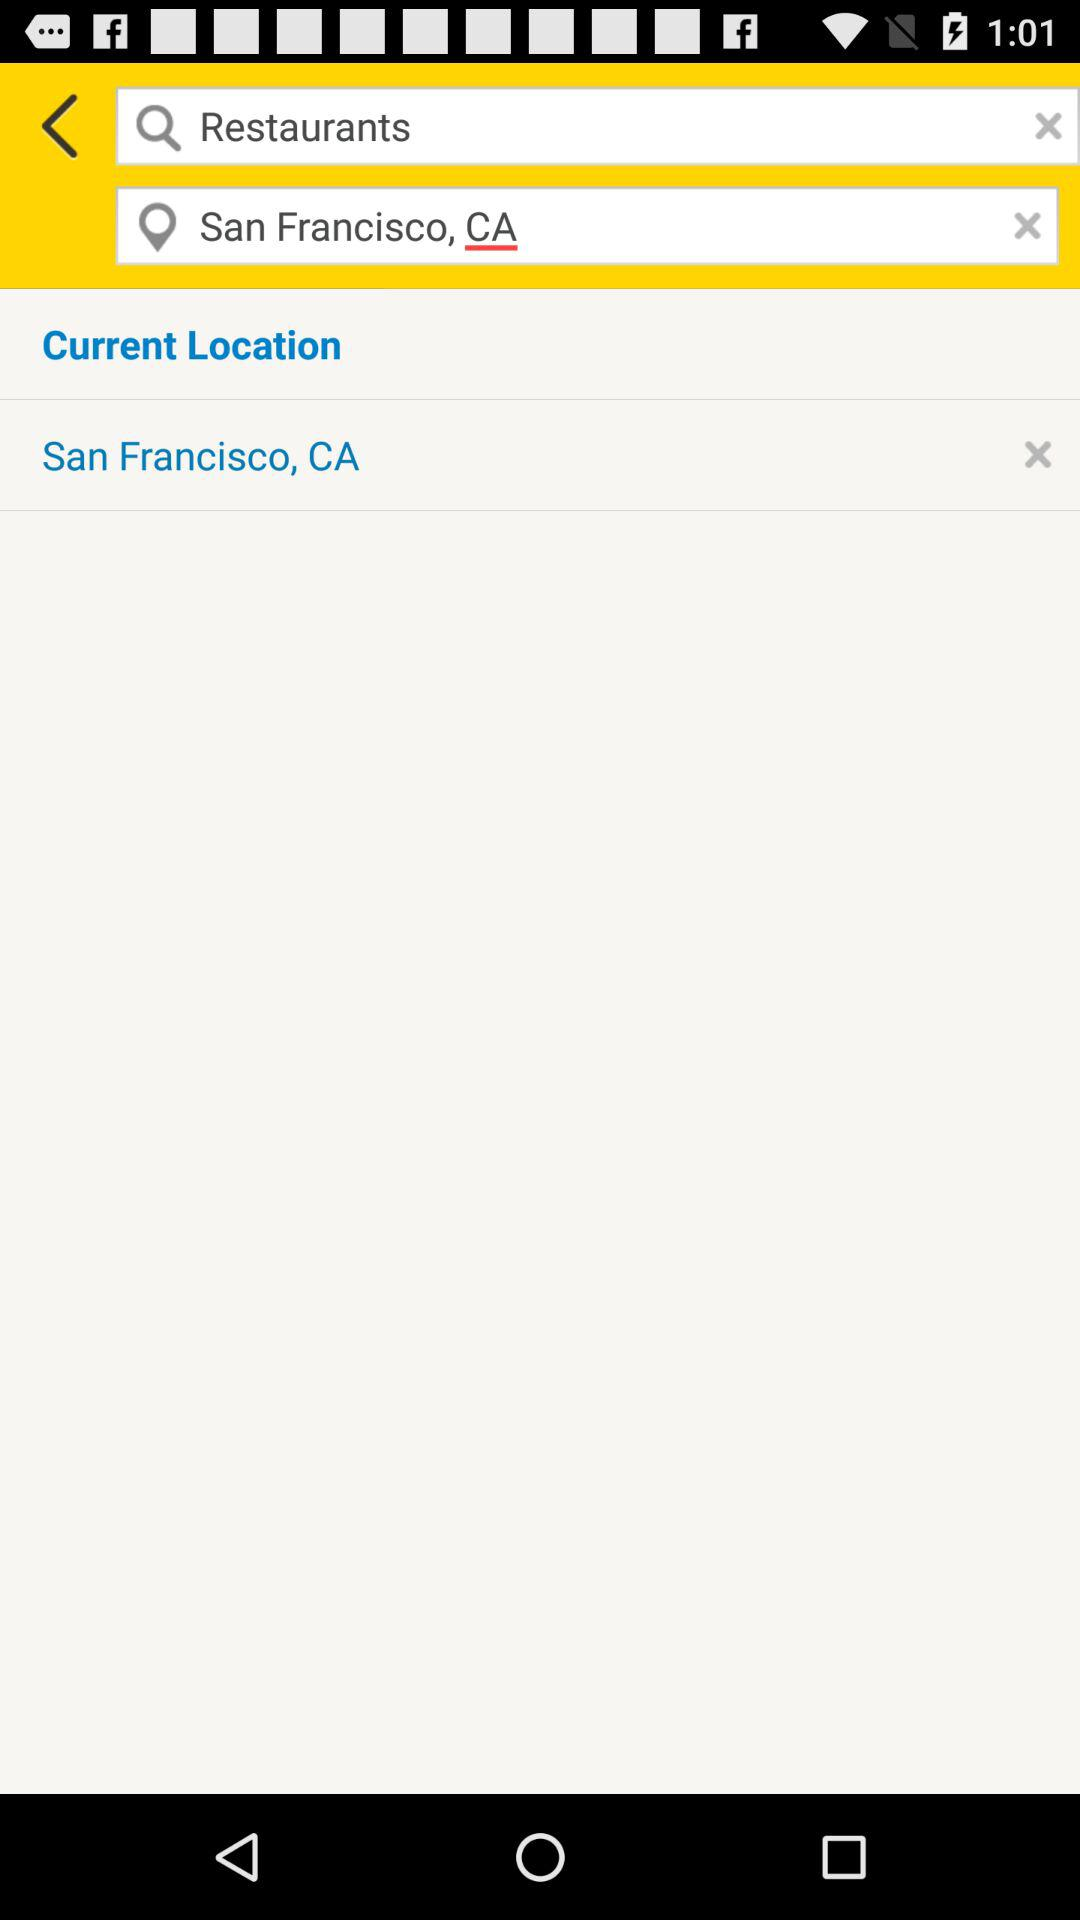What is the mentioned location? The mentioned location is San Francisco, CA. 